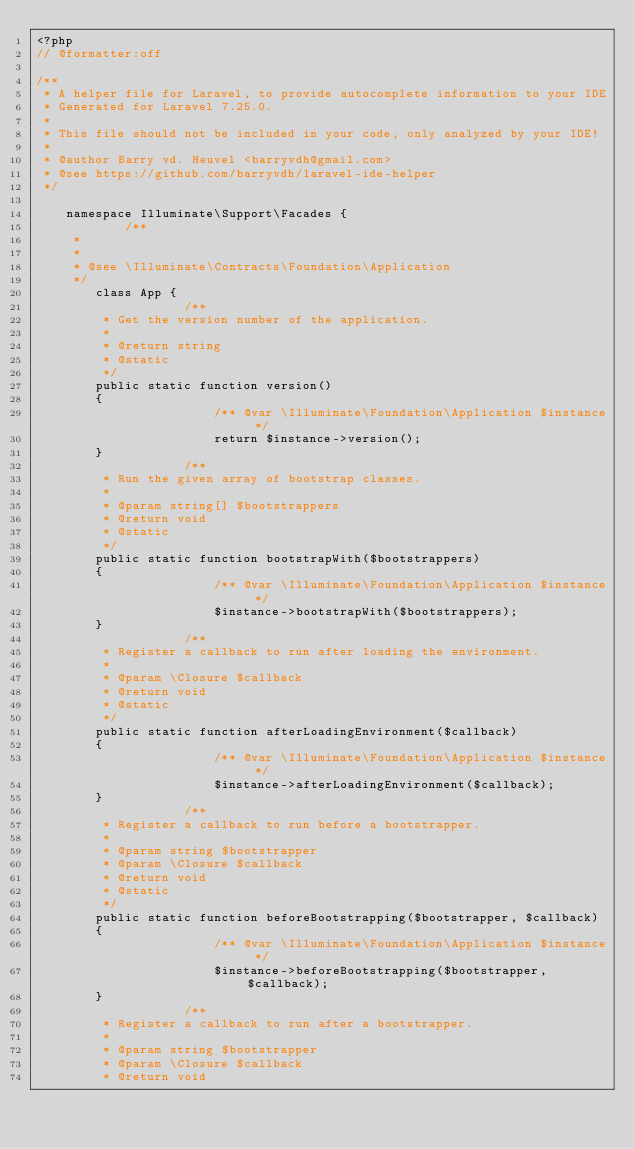Convert code to text. <code><loc_0><loc_0><loc_500><loc_500><_PHP_><?php
// @formatter:off

/**
 * A helper file for Laravel, to provide autocomplete information to your IDE
 * Generated for Laravel 7.25.0.
 *
 * This file should not be included in your code, only analyzed by your IDE!
 *
 * @author Barry vd. Heuvel <barryvdh@gmail.com>
 * @see https://github.com/barryvdh/laravel-ide-helper
 */

    namespace Illuminate\Support\Facades { 
            /**
     * 
     *
     * @see \Illuminate\Contracts\Foundation\Application
     */ 
        class App {
                    /**
         * Get the version number of the application.
         *
         * @return string 
         * @static 
         */ 
        public static function version()
        {
                        /** @var \Illuminate\Foundation\Application $instance */
                        return $instance->version();
        }
                    /**
         * Run the given array of bootstrap classes.
         *
         * @param string[] $bootstrappers
         * @return void 
         * @static 
         */ 
        public static function bootstrapWith($bootstrappers)
        {
                        /** @var \Illuminate\Foundation\Application $instance */
                        $instance->bootstrapWith($bootstrappers);
        }
                    /**
         * Register a callback to run after loading the environment.
         *
         * @param \Closure $callback
         * @return void 
         * @static 
         */ 
        public static function afterLoadingEnvironment($callback)
        {
                        /** @var \Illuminate\Foundation\Application $instance */
                        $instance->afterLoadingEnvironment($callback);
        }
                    /**
         * Register a callback to run before a bootstrapper.
         *
         * @param string $bootstrapper
         * @param \Closure $callback
         * @return void 
         * @static 
         */ 
        public static function beforeBootstrapping($bootstrapper, $callback)
        {
                        /** @var \Illuminate\Foundation\Application $instance */
                        $instance->beforeBootstrapping($bootstrapper, $callback);
        }
                    /**
         * Register a callback to run after a bootstrapper.
         *
         * @param string $bootstrapper
         * @param \Closure $callback
         * @return void </code> 